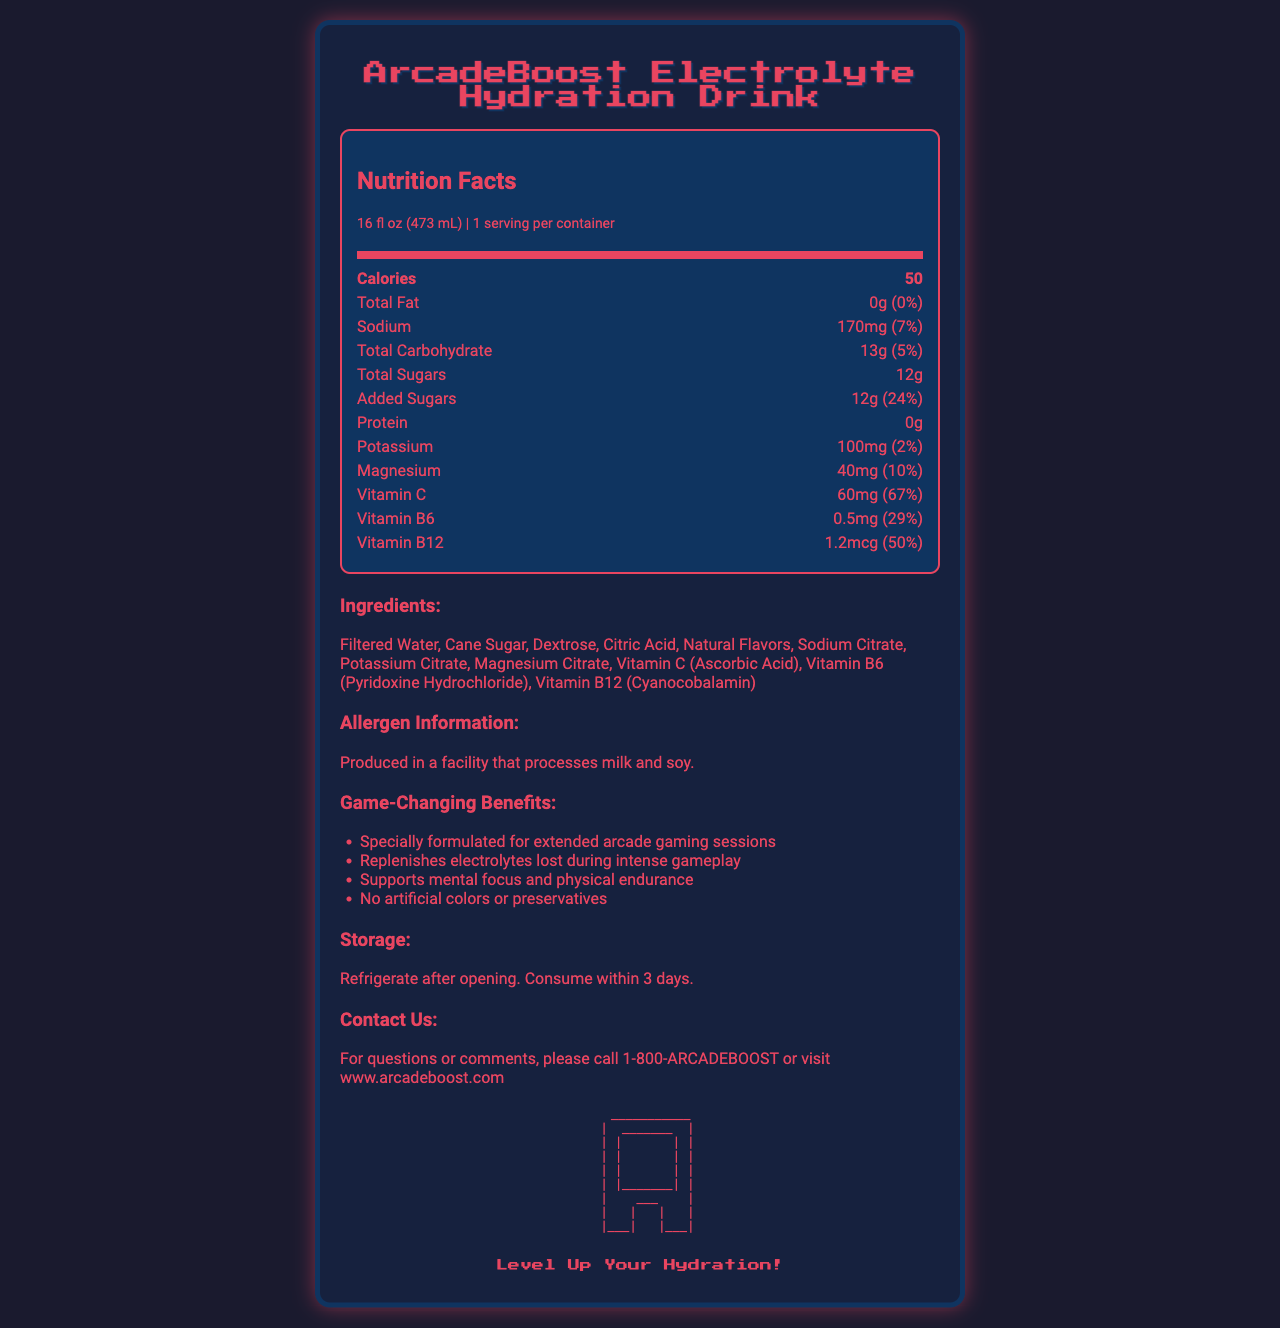what is the serving size of the ArcadeBoost Electrolyte Hydration Drink? The serving size is clearly stated in the section that mentions "Nutrition Facts" and indicates it as 16 fl oz (473 mL).
Answer: 16 fl oz (473 mL) how many calories are there in one serving of the drink? The number of calories is specified right under the "Nutrition Facts" section next to "Calories".
Answer: 50 how much total sugar does the drink contain per serving? The amount of total sugars is mentioned in the "Total Sugars" row in the "Nutrition Facts" table.
Answer: 12g what percentage of the daily value of Vitamin C is provided per serving? The daily value percentage of Vitamin C is listed next to "Vitamin C" in the "Nutrition Facts" table.
Answer: 67% list two ingredients found in the drink. The "Ingredients" section lists "Filtered Water" and "Cane Sugar" among others.
Answer: Filtered Water, Cane Sugar what is the sodium content in one serving of the drink? The sodium content is listed next to "Sodium" in the "Nutrition Facts" table.
Answer: 170mg how much potassium is in one serving of the drink? The potassium amount is listed next to "Potassium" in the "Nutrition Facts" table.
Answer: 100mg how should you store the drink after opening it? The storage instructions are provided under the "Storage" section.
Answer: Refrigerate after opening. Consume within 3 days. which vitamin has the highest daily value percentage in the drink? A. Vitamin C B. Vitamin B6 C. Vitamin B12 Vitamin C has a daily value of 67%, which is higher than Vitamin B6 (29%) and Vitamin B12 (50%).
Answer: A. Vitamin C who is the manufacturer of the drink? A. Arcade Essentials Distribution Co. B. GameFuel Beverages, Inc. C. ArcadeBoost Ltd. The "manufacturer" section indicates that the drink is produced by GameFuel Beverages, Inc.
Answer: B. GameFuel Beverages, Inc. does the drink contain any protein? The "Protein" row in the Nutrition Facts table indicates "0g".
Answer: No what is the main idea of the document? The document includes detailed sections on nutrition facts, ingredients, allergen information, marketing claims, storage instructions, and contact details, all formatted in a visually appealing manner to highlight the product's benefits and features.
Answer: The main idea of the document is to present the nutritional information, ingredients, allergen information, storage instructions, and contact details for the ArcadeBoost Electrolyte Hydration Drink, which is designed specially for extended arcade gaming sessions. does the drink contain any artificial colors or preservatives? According to the marketing claims section, the product has "No artificial colors or preservatives".
Answer: No how many flavors does the drink come in? The document does not specify how many flavors the drink comes in.
Answer: Not enough information 